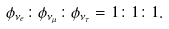<formula> <loc_0><loc_0><loc_500><loc_500>\phi _ { \nu _ { e } } \colon \phi _ { \nu _ { \mu } } \colon \phi _ { \nu _ { \tau } } = 1 \colon 1 \colon 1 .</formula> 